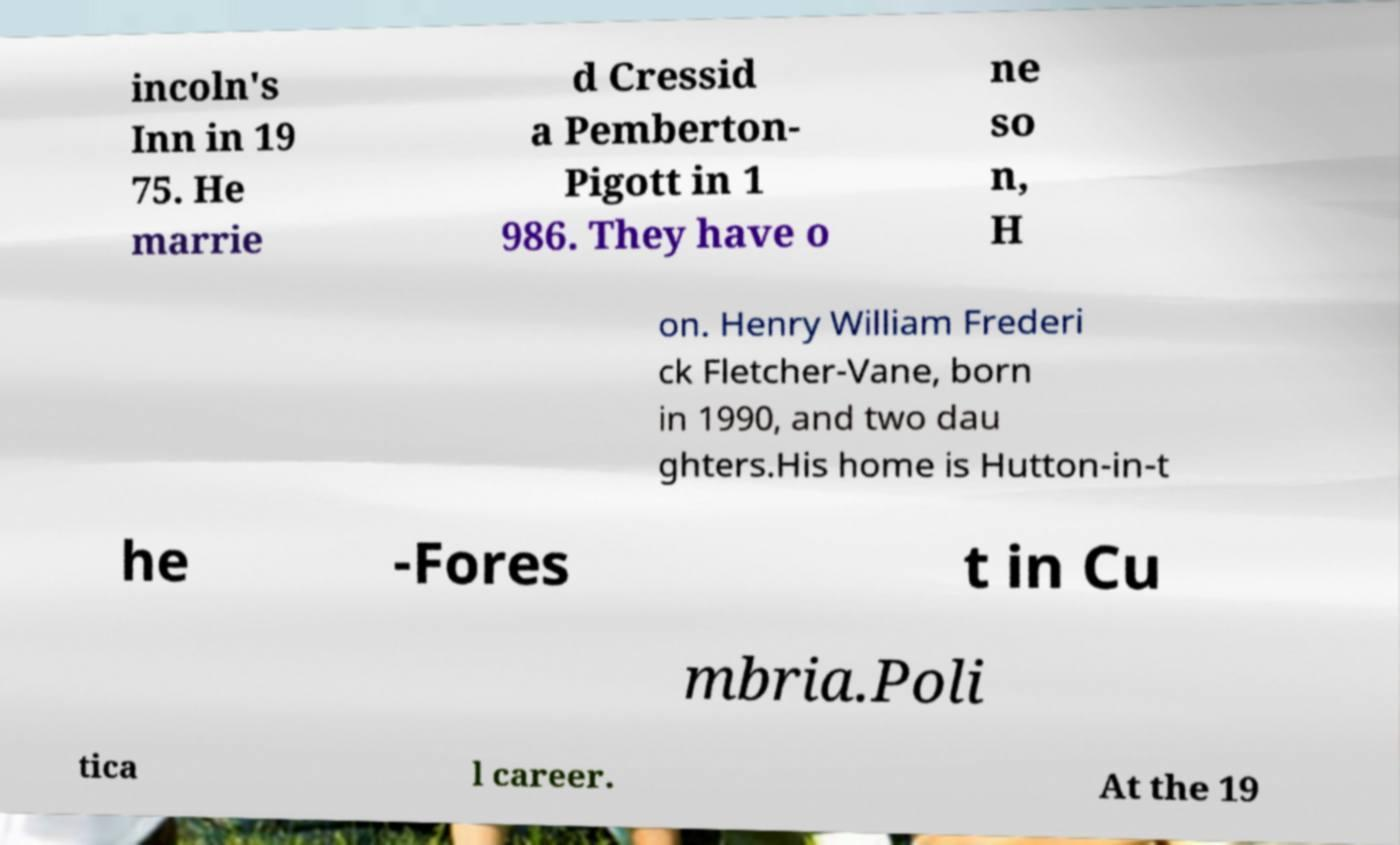What messages or text are displayed in this image? I need them in a readable, typed format. incoln's Inn in 19 75. He marrie d Cressid a Pemberton- Pigott in 1 986. They have o ne so n, H on. Henry William Frederi ck Fletcher-Vane, born in 1990, and two dau ghters.His home is Hutton-in-t he -Fores t in Cu mbria.Poli tica l career. At the 19 